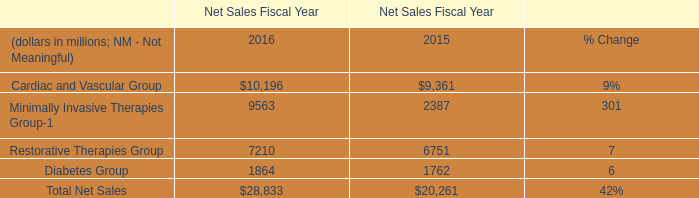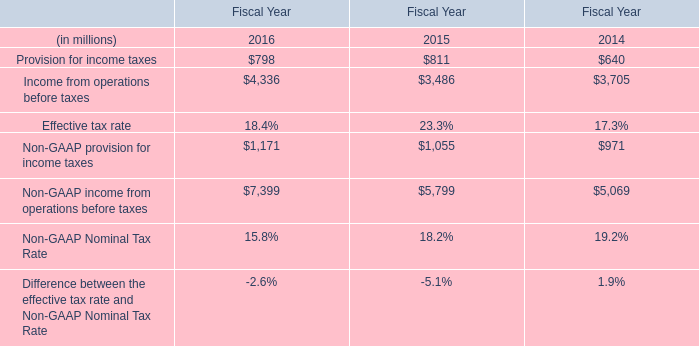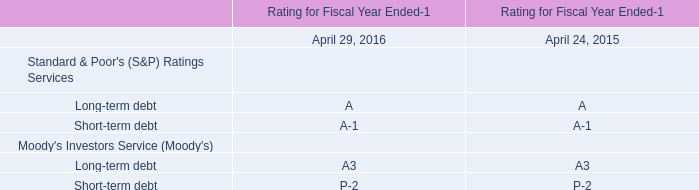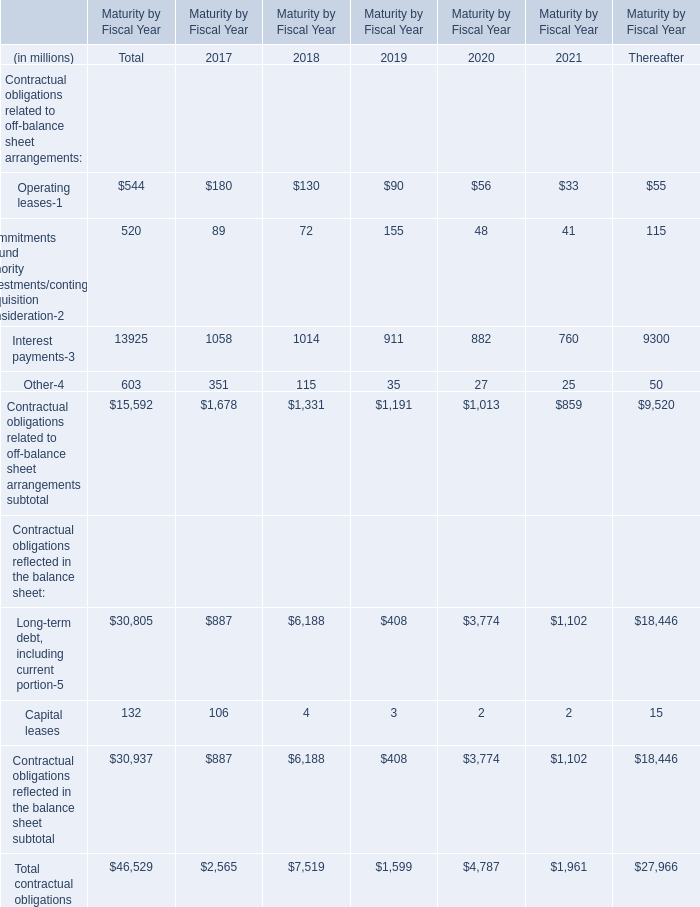What's the average of the Non-GAAP provision for income taxes in the years where Restorative Therapies Group is positive? (in million) 
Computations: ((1171 + 1055) / 2)
Answer: 1113.0. 